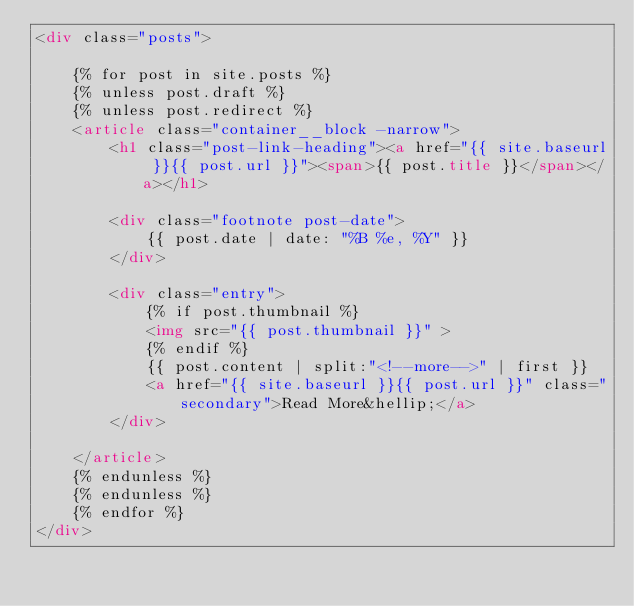<code> <loc_0><loc_0><loc_500><loc_500><_HTML_><div class="posts">

    {% for post in site.posts %}
    {% unless post.draft %}
    {% unless post.redirect %}
    <article class="container__block -narrow">
        <h1 class="post-link-heading"><a href="{{ site.baseurl }}{{ post.url }}"><span>{{ post.title }}</span></a></h1>

        <div class="footnote post-date">
            {{ post.date | date: "%B %e, %Y" }}
        </div>

        <div class="entry">
            {% if post.thumbnail %}
            <img src="{{ post.thumbnail }}" >
            {% endif %}
            {{ post.content | split:"<!--more-->" | first }}
            <a href="{{ site.baseurl }}{{ post.url }}" class="secondary">Read More&hellip;</a>
        </div>

    </article>
    {% endunless %}
    {% endunless %}
    {% endfor %}
</div>

</code> 